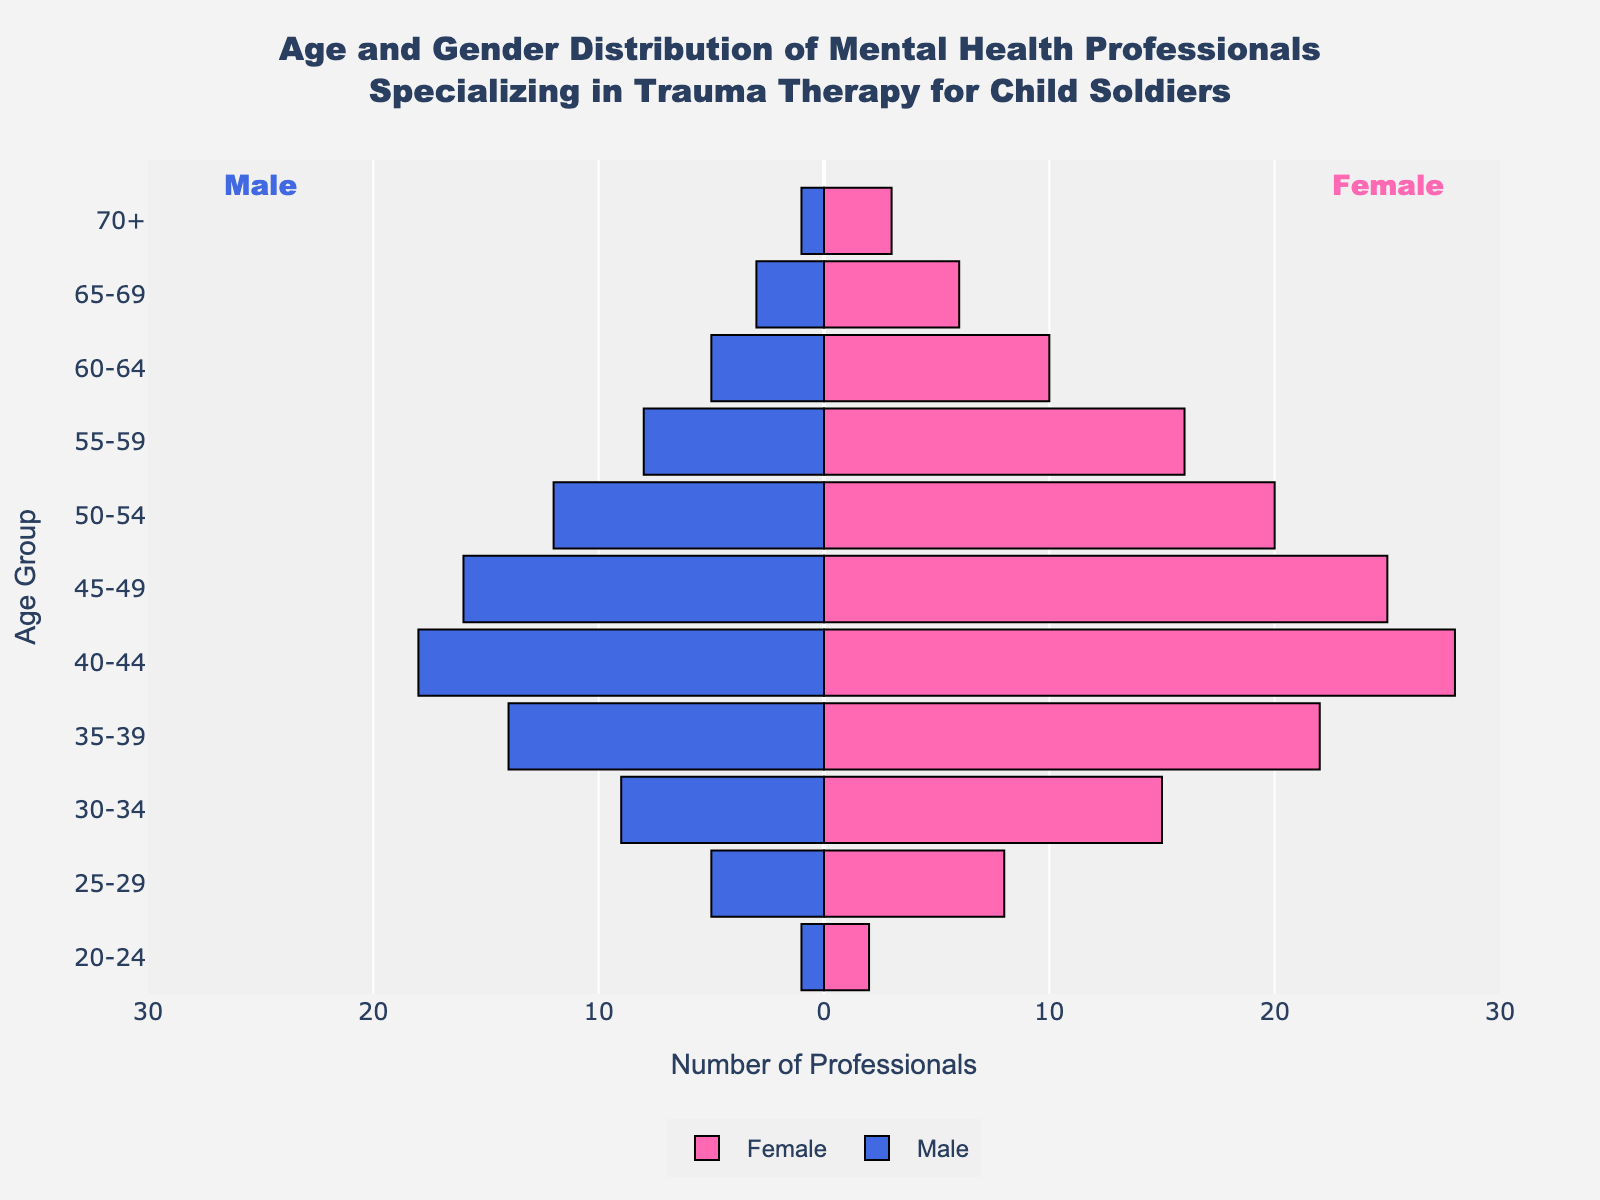What's the title of the figure? The title of the figure is placed at the top of the chart and provides an overview of what the figure represents. In this case, the title reads "Age and Gender Distribution of Mental Health Professionals Specializing in Trauma Therapy for Child Soldiers".
Answer: Age and Gender Distribution of Mental Health Professionals Specializing in Trauma Therapy for Child Soldiers How many age groups are represented in the figure? The figure displays data across different age ranges, each represented by a segment on the y-axis. By counting these segments, we can determine the number of age groups. There are 11 age groups in total.
Answer: 11 Which age group has the highest number of female professionals? To find the age group with the highest number of female professionals, we look for the segment with the longest pink bar, which represents females, on the right side of the pyramid. The age group 40-44 has the longest bar for females with a count of 28.
Answer: 40-44 In which age group is the gender ratio (female to male) closest to equal? To determine the age group with the closest female-to-male ratio, we need to find where the lengths of the pink and blue bars on either side of the pyramid are nearly equal. For the age group 55-59, the numbers are closest with 16 females and 8 males.
Answer: 55-59 What's the total number of male professionals in the 50-54 age group? To find the total number of male professionals in the age group 50-54, look at the corresponding blue bar on the left side of the pyramid. The number indicated is 12.
Answer: 12 How many more females than males are there in the age group 45-49? We need to subtract the number of males from the number of females in this age group. There are 25 females and 16 males in the 45-49 age group, so the difference is 25 - 16.
Answer: 9 Which age group has the least number of professionals in total, and how many are there? Summing both males and females for each age group and then finding the smallest total, we see that the 70+ age group has the least number with 3 females and 1 male. Therefore, the total is 3 + 1 = 4.
Answer: 70+, 4 What age group has the most significant gender gap? To find the age group with the most significant gender gap, calculate the absolute difference between the number of females and males in each age group. The age group 35-39 has a significant gap with 22 females and 14 males, a difference of 8.
Answer: 35-39 What's the combined total number of professionals aged 30-34 and 35-39? To find the total number of professionals in these age groups, sum the number of females and males in each and then add the totals for both age groups. For 30-34: 15 (females) + 9 (males) = 24. For 35-39: 22 (females) + 14 (males) = 36. Adding both gives 24 + 36.
Answer: 60 